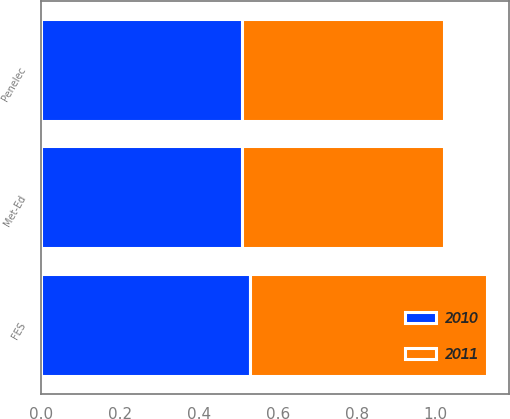<chart> <loc_0><loc_0><loc_500><loc_500><stacked_bar_chart><ecel><fcel>FES<fcel>Met-Ed<fcel>Penelec<nl><fcel>2010<fcel>0.53<fcel>0.51<fcel>0.51<nl><fcel>2011<fcel>0.6<fcel>0.51<fcel>0.51<nl></chart> 